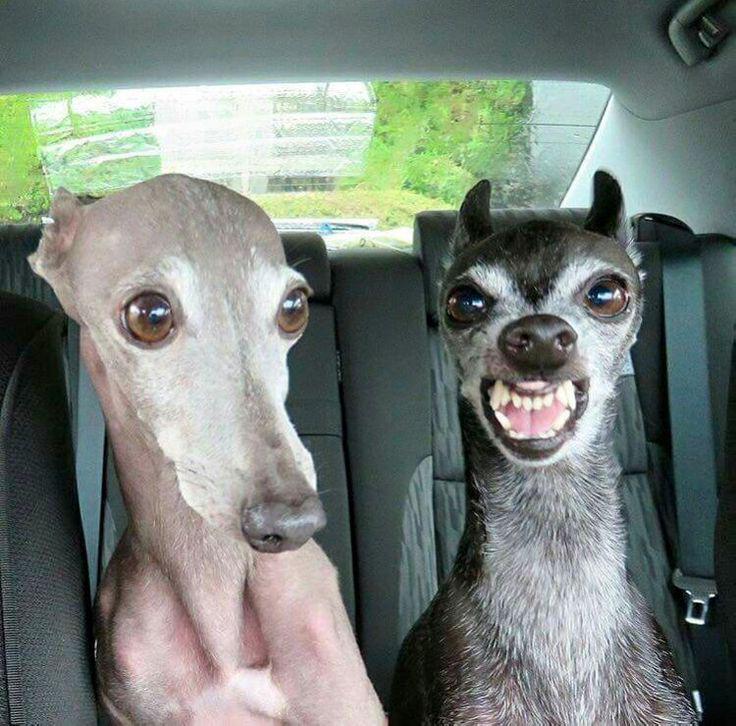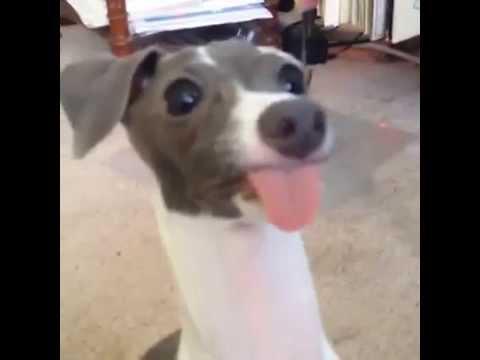The first image is the image on the left, the second image is the image on the right. Evaluate the accuracy of this statement regarding the images: "Two dogs are near each other and 1 of them has its teeth showing.". Is it true? Answer yes or no. Yes. The first image is the image on the left, the second image is the image on the right. Given the left and right images, does the statement "a dog has it's tongue sticking out" hold true? Answer yes or no. Yes. 